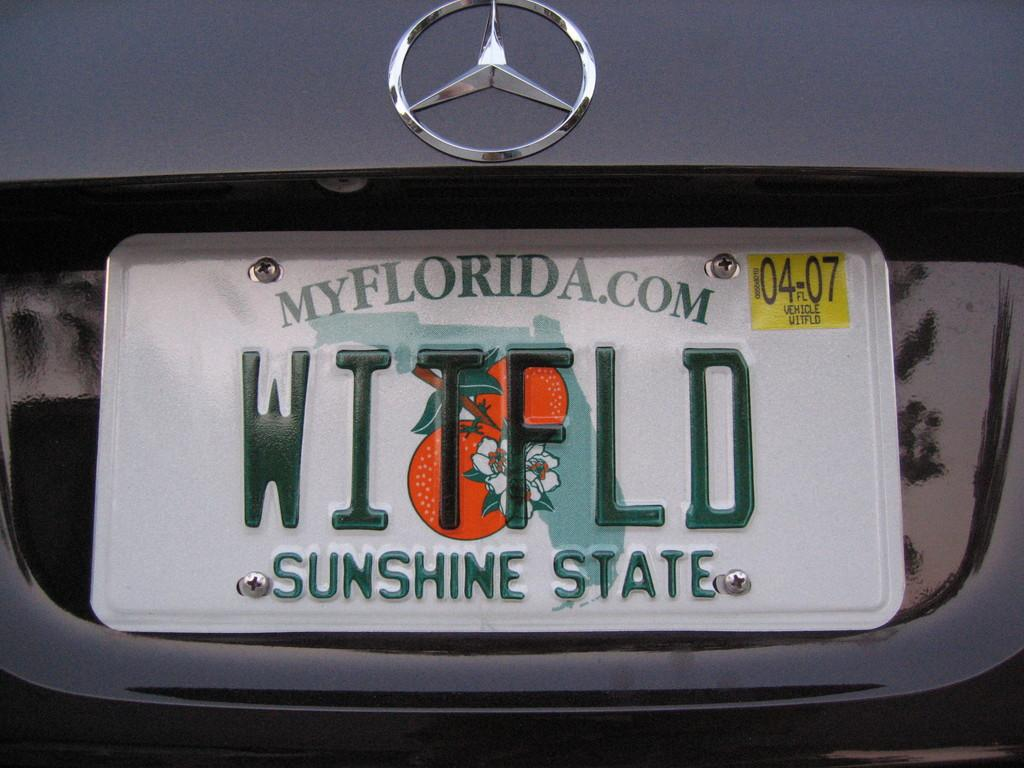<image>
Give a short and clear explanation of the subsequent image. a florida.com ad on a license plate with oranges 